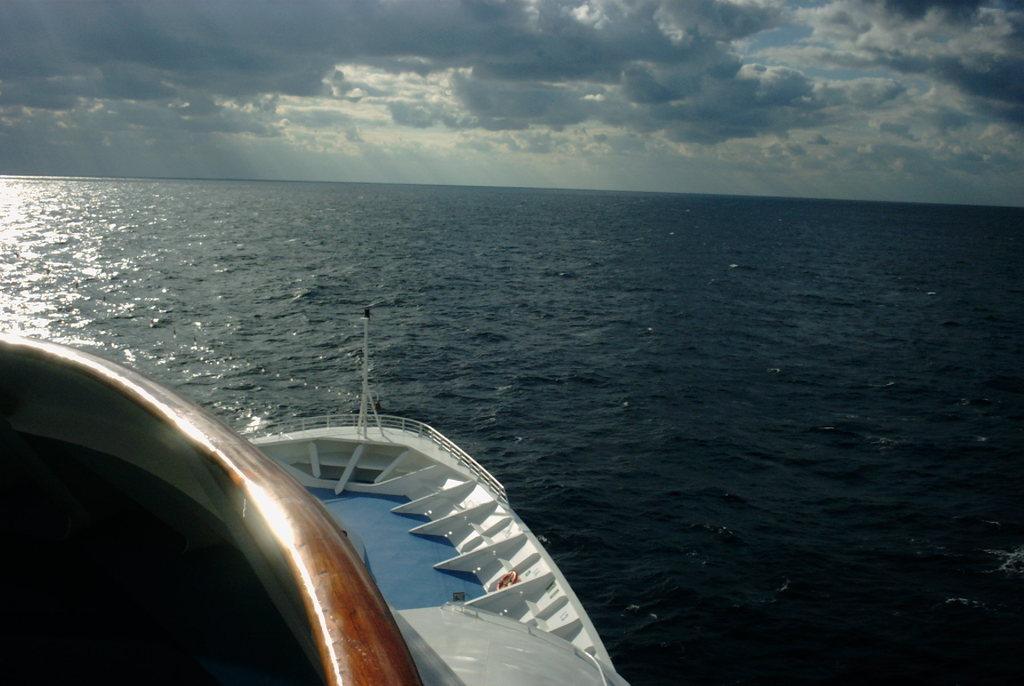Could you give a brief overview of what you see in this image? In the foreground of the picture it is a ship. In this picture there is a water body might be an ocean. At the top it is sky, sky is partially cloudy. 